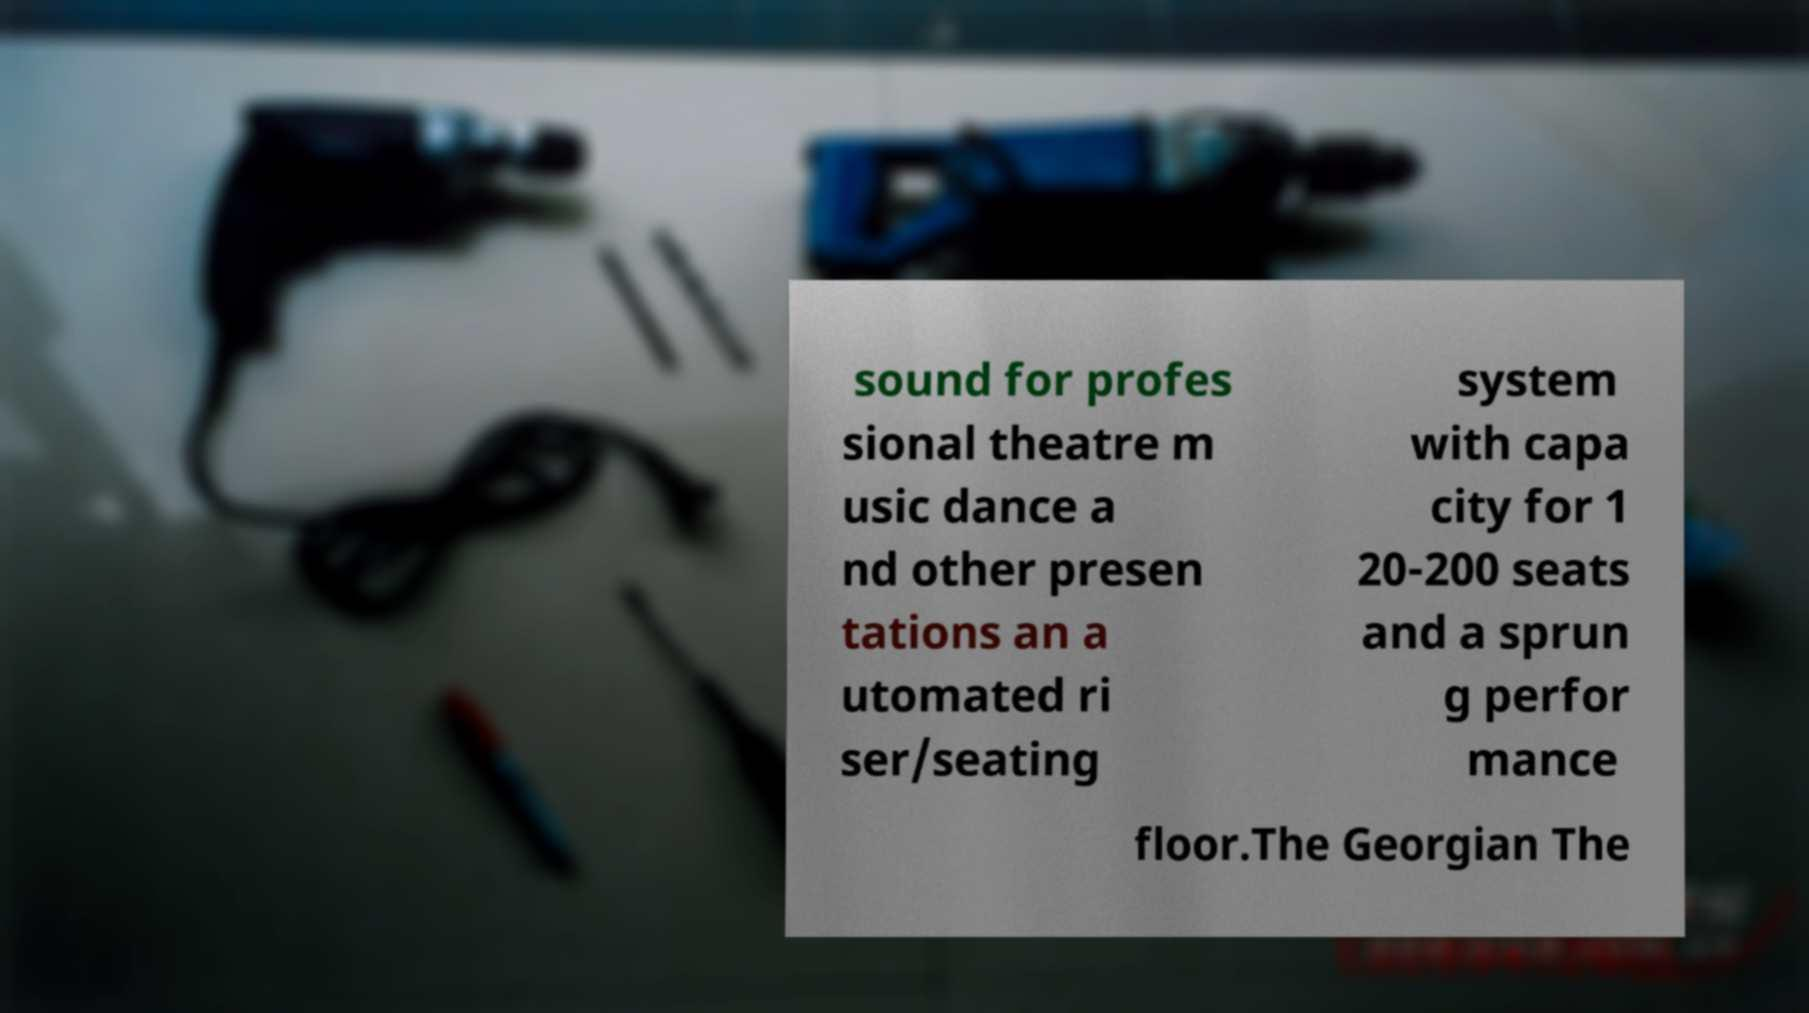Could you extract and type out the text from this image? sound for profes sional theatre m usic dance a nd other presen tations an a utomated ri ser/seating system with capa city for 1 20-200 seats and a sprun g perfor mance floor.The Georgian The 